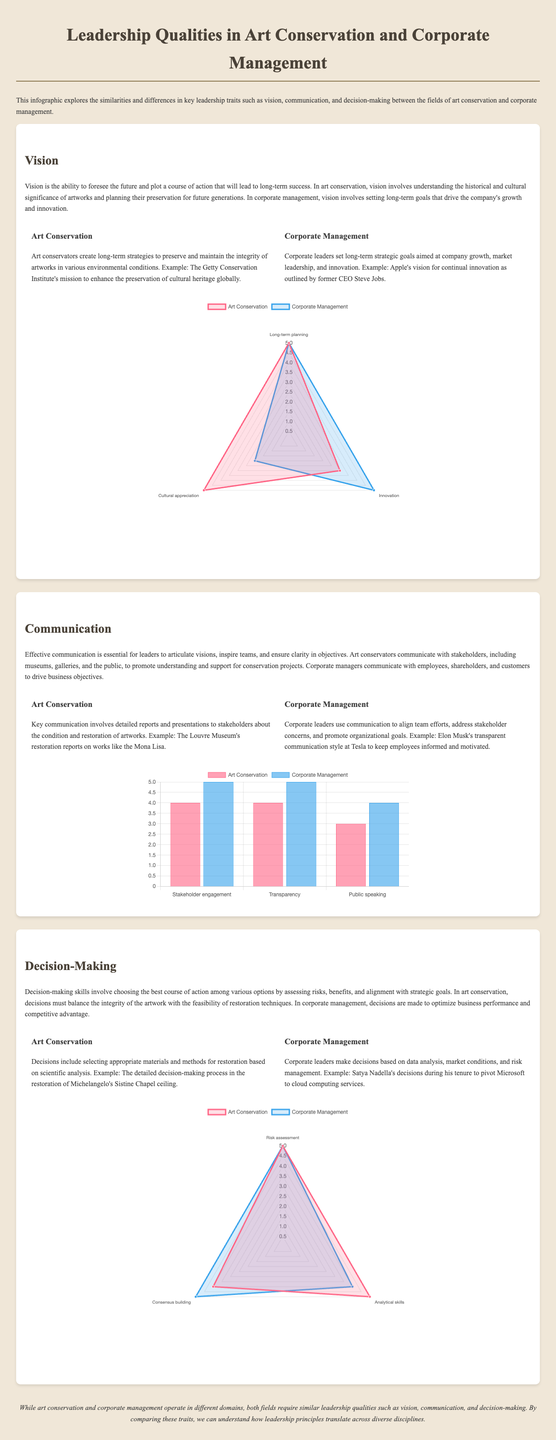What are the key leadership traits discussed in the infographic? The infographic discusses vision, communication, and decision-making as key leadership traits.
Answer: vision, communication, decision-making What is the highest rating for vision in Art Conservation? The radar chart shows the highest score for vision in Art Conservation is 5 out of 5.
Answer: 5 Which organization’s mission is mentioned as an example of Art Conservation's vision? The document mentions the Getty Conservation Institute's mission as an example of vision in Art Conservation.
Answer: Getty Conservation Institute What aspect of communication has the highest rating in Corporate Management? According to the bar chart, stakeholder engagement in Corporate Management has the highest rating of 5.
Answer: 5 What is the rating for consensus building in Art Conservation? The radar chart shows that consensus building in Art Conservation has a rating of 4.
Answer: 4 Which leader's communication style is referenced as an example in Corporate Management? The infographic mentions Elon Musk's transparent communication style at Tesla as an example in Corporate Management.
Answer: Elon Musk What scale is used to measure Decision-Making skills in the charts? The scale used in the charts for Decision-Making skills ranges from 0 to 5.
Answer: 0 to 5 What is the conclusion drawn in the infographic? The conclusion states that both fields require similar leadership qualities such as vision, communication, and decision-making.
Answer: similar leadership qualities What type of chart is used to represent Communication? A bar chart is used to represent Communication in the infographic.
Answer: bar chart 